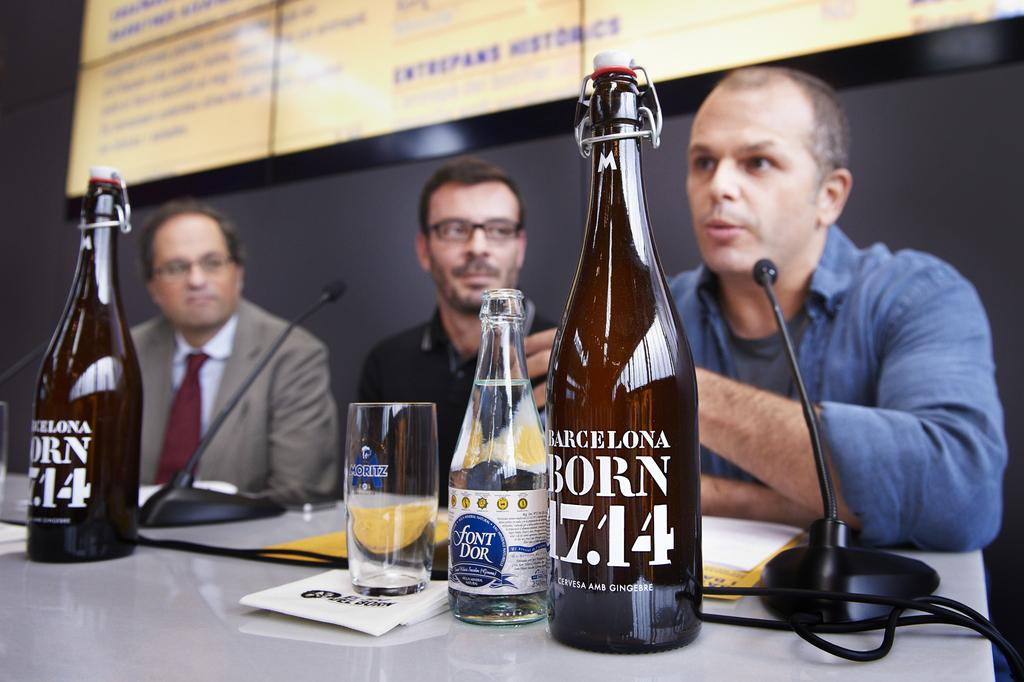<image>
Write a terse but informative summary of the picture. A bottle with 17.4 sits on a table in front of a man. 